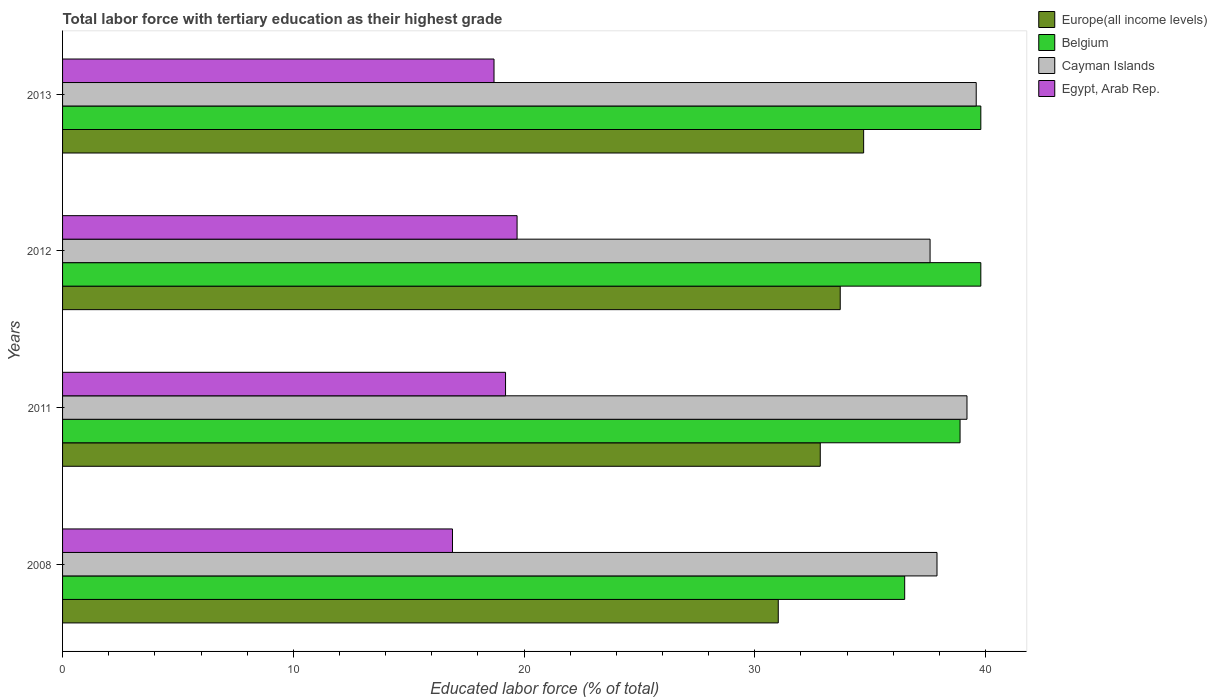How many different coloured bars are there?
Provide a succinct answer. 4. Are the number of bars per tick equal to the number of legend labels?
Offer a very short reply. Yes. How many bars are there on the 4th tick from the bottom?
Give a very brief answer. 4. In how many cases, is the number of bars for a given year not equal to the number of legend labels?
Your answer should be compact. 0. What is the percentage of male labor force with tertiary education in Egypt, Arab Rep. in 2008?
Offer a very short reply. 16.9. Across all years, what is the maximum percentage of male labor force with tertiary education in Egypt, Arab Rep.?
Keep it short and to the point. 19.7. Across all years, what is the minimum percentage of male labor force with tertiary education in Cayman Islands?
Provide a short and direct response. 37.6. In which year was the percentage of male labor force with tertiary education in Cayman Islands minimum?
Your answer should be compact. 2012. What is the total percentage of male labor force with tertiary education in Belgium in the graph?
Keep it short and to the point. 155. What is the difference between the percentage of male labor force with tertiary education in Belgium in 2008 and that in 2013?
Your answer should be very brief. -3.3. What is the difference between the percentage of male labor force with tertiary education in Belgium in 2011 and the percentage of male labor force with tertiary education in Europe(all income levels) in 2008?
Make the answer very short. 7.88. What is the average percentage of male labor force with tertiary education in Europe(all income levels) per year?
Give a very brief answer. 33.07. In the year 2012, what is the difference between the percentage of male labor force with tertiary education in Europe(all income levels) and percentage of male labor force with tertiary education in Belgium?
Provide a succinct answer. -6.09. In how many years, is the percentage of male labor force with tertiary education in Egypt, Arab Rep. greater than 12 %?
Your response must be concise. 4. What is the ratio of the percentage of male labor force with tertiary education in Egypt, Arab Rep. in 2011 to that in 2013?
Keep it short and to the point. 1.03. Is the difference between the percentage of male labor force with tertiary education in Europe(all income levels) in 2011 and 2013 greater than the difference between the percentage of male labor force with tertiary education in Belgium in 2011 and 2013?
Provide a succinct answer. No. What is the difference between the highest and the lowest percentage of male labor force with tertiary education in Egypt, Arab Rep.?
Provide a short and direct response. 2.8. In how many years, is the percentage of male labor force with tertiary education in Europe(all income levels) greater than the average percentage of male labor force with tertiary education in Europe(all income levels) taken over all years?
Provide a short and direct response. 2. Is the sum of the percentage of male labor force with tertiary education in Egypt, Arab Rep. in 2011 and 2013 greater than the maximum percentage of male labor force with tertiary education in Cayman Islands across all years?
Offer a very short reply. No. Is it the case that in every year, the sum of the percentage of male labor force with tertiary education in Europe(all income levels) and percentage of male labor force with tertiary education in Cayman Islands is greater than the sum of percentage of male labor force with tertiary education in Egypt, Arab Rep. and percentage of male labor force with tertiary education in Belgium?
Offer a very short reply. No. What does the 4th bar from the bottom in 2011 represents?
Ensure brevity in your answer.  Egypt, Arab Rep. Is it the case that in every year, the sum of the percentage of male labor force with tertiary education in Cayman Islands and percentage of male labor force with tertiary education in Belgium is greater than the percentage of male labor force with tertiary education in Egypt, Arab Rep.?
Your answer should be compact. Yes. How many bars are there?
Offer a very short reply. 16. Are all the bars in the graph horizontal?
Ensure brevity in your answer.  Yes. What is the difference between two consecutive major ticks on the X-axis?
Provide a short and direct response. 10. Are the values on the major ticks of X-axis written in scientific E-notation?
Offer a very short reply. No. Does the graph contain any zero values?
Offer a very short reply. No. How are the legend labels stacked?
Your answer should be very brief. Vertical. What is the title of the graph?
Your answer should be very brief. Total labor force with tertiary education as their highest grade. Does "OECD members" appear as one of the legend labels in the graph?
Provide a succinct answer. No. What is the label or title of the X-axis?
Ensure brevity in your answer.  Educated labor force (% of total). What is the label or title of the Y-axis?
Your response must be concise. Years. What is the Educated labor force (% of total) in Europe(all income levels) in 2008?
Make the answer very short. 31.02. What is the Educated labor force (% of total) of Belgium in 2008?
Provide a short and direct response. 36.5. What is the Educated labor force (% of total) of Cayman Islands in 2008?
Offer a very short reply. 37.9. What is the Educated labor force (% of total) of Egypt, Arab Rep. in 2008?
Offer a very short reply. 16.9. What is the Educated labor force (% of total) of Europe(all income levels) in 2011?
Provide a short and direct response. 32.84. What is the Educated labor force (% of total) of Belgium in 2011?
Give a very brief answer. 38.9. What is the Educated labor force (% of total) in Cayman Islands in 2011?
Your response must be concise. 39.2. What is the Educated labor force (% of total) of Egypt, Arab Rep. in 2011?
Make the answer very short. 19.2. What is the Educated labor force (% of total) of Europe(all income levels) in 2012?
Give a very brief answer. 33.71. What is the Educated labor force (% of total) of Belgium in 2012?
Ensure brevity in your answer.  39.8. What is the Educated labor force (% of total) in Cayman Islands in 2012?
Give a very brief answer. 37.6. What is the Educated labor force (% of total) of Egypt, Arab Rep. in 2012?
Provide a short and direct response. 19.7. What is the Educated labor force (% of total) in Europe(all income levels) in 2013?
Offer a terse response. 34.72. What is the Educated labor force (% of total) in Belgium in 2013?
Ensure brevity in your answer.  39.8. What is the Educated labor force (% of total) of Cayman Islands in 2013?
Provide a short and direct response. 39.6. What is the Educated labor force (% of total) of Egypt, Arab Rep. in 2013?
Ensure brevity in your answer.  18.7. Across all years, what is the maximum Educated labor force (% of total) of Europe(all income levels)?
Your answer should be compact. 34.72. Across all years, what is the maximum Educated labor force (% of total) in Belgium?
Offer a terse response. 39.8. Across all years, what is the maximum Educated labor force (% of total) in Cayman Islands?
Make the answer very short. 39.6. Across all years, what is the maximum Educated labor force (% of total) in Egypt, Arab Rep.?
Offer a very short reply. 19.7. Across all years, what is the minimum Educated labor force (% of total) in Europe(all income levels)?
Your answer should be compact. 31.02. Across all years, what is the minimum Educated labor force (% of total) in Belgium?
Offer a terse response. 36.5. Across all years, what is the minimum Educated labor force (% of total) of Cayman Islands?
Offer a very short reply. 37.6. Across all years, what is the minimum Educated labor force (% of total) of Egypt, Arab Rep.?
Provide a short and direct response. 16.9. What is the total Educated labor force (% of total) of Europe(all income levels) in the graph?
Provide a short and direct response. 132.29. What is the total Educated labor force (% of total) in Belgium in the graph?
Offer a terse response. 155. What is the total Educated labor force (% of total) of Cayman Islands in the graph?
Your response must be concise. 154.3. What is the total Educated labor force (% of total) of Egypt, Arab Rep. in the graph?
Make the answer very short. 74.5. What is the difference between the Educated labor force (% of total) of Europe(all income levels) in 2008 and that in 2011?
Ensure brevity in your answer.  -1.82. What is the difference between the Educated labor force (% of total) in Europe(all income levels) in 2008 and that in 2012?
Provide a short and direct response. -2.69. What is the difference between the Educated labor force (% of total) of Belgium in 2008 and that in 2012?
Offer a very short reply. -3.3. What is the difference between the Educated labor force (% of total) in Europe(all income levels) in 2008 and that in 2013?
Your answer should be compact. -3.7. What is the difference between the Educated labor force (% of total) of Europe(all income levels) in 2011 and that in 2012?
Provide a short and direct response. -0.87. What is the difference between the Educated labor force (% of total) in Cayman Islands in 2011 and that in 2012?
Your response must be concise. 1.6. What is the difference between the Educated labor force (% of total) in Europe(all income levels) in 2011 and that in 2013?
Offer a very short reply. -1.88. What is the difference between the Educated labor force (% of total) in Egypt, Arab Rep. in 2011 and that in 2013?
Offer a terse response. 0.5. What is the difference between the Educated labor force (% of total) of Europe(all income levels) in 2012 and that in 2013?
Offer a very short reply. -1.01. What is the difference between the Educated labor force (% of total) of Europe(all income levels) in 2008 and the Educated labor force (% of total) of Belgium in 2011?
Your response must be concise. -7.88. What is the difference between the Educated labor force (% of total) of Europe(all income levels) in 2008 and the Educated labor force (% of total) of Cayman Islands in 2011?
Offer a very short reply. -8.18. What is the difference between the Educated labor force (% of total) of Europe(all income levels) in 2008 and the Educated labor force (% of total) of Egypt, Arab Rep. in 2011?
Provide a short and direct response. 11.82. What is the difference between the Educated labor force (% of total) in Belgium in 2008 and the Educated labor force (% of total) in Egypt, Arab Rep. in 2011?
Give a very brief answer. 17.3. What is the difference between the Educated labor force (% of total) of Cayman Islands in 2008 and the Educated labor force (% of total) of Egypt, Arab Rep. in 2011?
Offer a very short reply. 18.7. What is the difference between the Educated labor force (% of total) in Europe(all income levels) in 2008 and the Educated labor force (% of total) in Belgium in 2012?
Keep it short and to the point. -8.78. What is the difference between the Educated labor force (% of total) of Europe(all income levels) in 2008 and the Educated labor force (% of total) of Cayman Islands in 2012?
Keep it short and to the point. -6.58. What is the difference between the Educated labor force (% of total) of Europe(all income levels) in 2008 and the Educated labor force (% of total) of Egypt, Arab Rep. in 2012?
Provide a short and direct response. 11.32. What is the difference between the Educated labor force (% of total) of Cayman Islands in 2008 and the Educated labor force (% of total) of Egypt, Arab Rep. in 2012?
Give a very brief answer. 18.2. What is the difference between the Educated labor force (% of total) in Europe(all income levels) in 2008 and the Educated labor force (% of total) in Belgium in 2013?
Make the answer very short. -8.78. What is the difference between the Educated labor force (% of total) of Europe(all income levels) in 2008 and the Educated labor force (% of total) of Cayman Islands in 2013?
Provide a short and direct response. -8.58. What is the difference between the Educated labor force (% of total) in Europe(all income levels) in 2008 and the Educated labor force (% of total) in Egypt, Arab Rep. in 2013?
Give a very brief answer. 12.32. What is the difference between the Educated labor force (% of total) in Belgium in 2008 and the Educated labor force (% of total) in Cayman Islands in 2013?
Give a very brief answer. -3.1. What is the difference between the Educated labor force (% of total) in Belgium in 2008 and the Educated labor force (% of total) in Egypt, Arab Rep. in 2013?
Offer a terse response. 17.8. What is the difference between the Educated labor force (% of total) in Cayman Islands in 2008 and the Educated labor force (% of total) in Egypt, Arab Rep. in 2013?
Make the answer very short. 19.2. What is the difference between the Educated labor force (% of total) in Europe(all income levels) in 2011 and the Educated labor force (% of total) in Belgium in 2012?
Your answer should be compact. -6.96. What is the difference between the Educated labor force (% of total) of Europe(all income levels) in 2011 and the Educated labor force (% of total) of Cayman Islands in 2012?
Offer a very short reply. -4.76. What is the difference between the Educated labor force (% of total) of Europe(all income levels) in 2011 and the Educated labor force (% of total) of Egypt, Arab Rep. in 2012?
Ensure brevity in your answer.  13.14. What is the difference between the Educated labor force (% of total) of Belgium in 2011 and the Educated labor force (% of total) of Cayman Islands in 2012?
Offer a very short reply. 1.3. What is the difference between the Educated labor force (% of total) of Europe(all income levels) in 2011 and the Educated labor force (% of total) of Belgium in 2013?
Keep it short and to the point. -6.96. What is the difference between the Educated labor force (% of total) of Europe(all income levels) in 2011 and the Educated labor force (% of total) of Cayman Islands in 2013?
Provide a succinct answer. -6.76. What is the difference between the Educated labor force (% of total) in Europe(all income levels) in 2011 and the Educated labor force (% of total) in Egypt, Arab Rep. in 2013?
Keep it short and to the point. 14.14. What is the difference between the Educated labor force (% of total) in Belgium in 2011 and the Educated labor force (% of total) in Egypt, Arab Rep. in 2013?
Your answer should be very brief. 20.2. What is the difference between the Educated labor force (% of total) of Cayman Islands in 2011 and the Educated labor force (% of total) of Egypt, Arab Rep. in 2013?
Offer a terse response. 20.5. What is the difference between the Educated labor force (% of total) of Europe(all income levels) in 2012 and the Educated labor force (% of total) of Belgium in 2013?
Your answer should be very brief. -6.09. What is the difference between the Educated labor force (% of total) of Europe(all income levels) in 2012 and the Educated labor force (% of total) of Cayman Islands in 2013?
Provide a short and direct response. -5.89. What is the difference between the Educated labor force (% of total) in Europe(all income levels) in 2012 and the Educated labor force (% of total) in Egypt, Arab Rep. in 2013?
Provide a succinct answer. 15.01. What is the difference between the Educated labor force (% of total) of Belgium in 2012 and the Educated labor force (% of total) of Egypt, Arab Rep. in 2013?
Give a very brief answer. 21.1. What is the difference between the Educated labor force (% of total) of Cayman Islands in 2012 and the Educated labor force (% of total) of Egypt, Arab Rep. in 2013?
Keep it short and to the point. 18.9. What is the average Educated labor force (% of total) of Europe(all income levels) per year?
Your answer should be compact. 33.07. What is the average Educated labor force (% of total) of Belgium per year?
Offer a terse response. 38.75. What is the average Educated labor force (% of total) of Cayman Islands per year?
Offer a terse response. 38.58. What is the average Educated labor force (% of total) in Egypt, Arab Rep. per year?
Offer a terse response. 18.62. In the year 2008, what is the difference between the Educated labor force (% of total) in Europe(all income levels) and Educated labor force (% of total) in Belgium?
Provide a succinct answer. -5.48. In the year 2008, what is the difference between the Educated labor force (% of total) of Europe(all income levels) and Educated labor force (% of total) of Cayman Islands?
Ensure brevity in your answer.  -6.88. In the year 2008, what is the difference between the Educated labor force (% of total) in Europe(all income levels) and Educated labor force (% of total) in Egypt, Arab Rep.?
Provide a short and direct response. 14.12. In the year 2008, what is the difference between the Educated labor force (% of total) in Belgium and Educated labor force (% of total) in Egypt, Arab Rep.?
Give a very brief answer. 19.6. In the year 2008, what is the difference between the Educated labor force (% of total) in Cayman Islands and Educated labor force (% of total) in Egypt, Arab Rep.?
Offer a terse response. 21. In the year 2011, what is the difference between the Educated labor force (% of total) of Europe(all income levels) and Educated labor force (% of total) of Belgium?
Offer a terse response. -6.06. In the year 2011, what is the difference between the Educated labor force (% of total) in Europe(all income levels) and Educated labor force (% of total) in Cayman Islands?
Make the answer very short. -6.36. In the year 2011, what is the difference between the Educated labor force (% of total) in Europe(all income levels) and Educated labor force (% of total) in Egypt, Arab Rep.?
Your answer should be compact. 13.64. In the year 2011, what is the difference between the Educated labor force (% of total) of Belgium and Educated labor force (% of total) of Egypt, Arab Rep.?
Your answer should be very brief. 19.7. In the year 2012, what is the difference between the Educated labor force (% of total) of Europe(all income levels) and Educated labor force (% of total) of Belgium?
Keep it short and to the point. -6.09. In the year 2012, what is the difference between the Educated labor force (% of total) of Europe(all income levels) and Educated labor force (% of total) of Cayman Islands?
Give a very brief answer. -3.89. In the year 2012, what is the difference between the Educated labor force (% of total) of Europe(all income levels) and Educated labor force (% of total) of Egypt, Arab Rep.?
Keep it short and to the point. 14.01. In the year 2012, what is the difference between the Educated labor force (% of total) in Belgium and Educated labor force (% of total) in Cayman Islands?
Your answer should be compact. 2.2. In the year 2012, what is the difference between the Educated labor force (% of total) of Belgium and Educated labor force (% of total) of Egypt, Arab Rep.?
Ensure brevity in your answer.  20.1. In the year 2012, what is the difference between the Educated labor force (% of total) of Cayman Islands and Educated labor force (% of total) of Egypt, Arab Rep.?
Offer a terse response. 17.9. In the year 2013, what is the difference between the Educated labor force (% of total) in Europe(all income levels) and Educated labor force (% of total) in Belgium?
Your response must be concise. -5.08. In the year 2013, what is the difference between the Educated labor force (% of total) in Europe(all income levels) and Educated labor force (% of total) in Cayman Islands?
Provide a succinct answer. -4.88. In the year 2013, what is the difference between the Educated labor force (% of total) of Europe(all income levels) and Educated labor force (% of total) of Egypt, Arab Rep.?
Make the answer very short. 16.02. In the year 2013, what is the difference between the Educated labor force (% of total) in Belgium and Educated labor force (% of total) in Egypt, Arab Rep.?
Provide a short and direct response. 21.1. In the year 2013, what is the difference between the Educated labor force (% of total) of Cayman Islands and Educated labor force (% of total) of Egypt, Arab Rep.?
Provide a succinct answer. 20.9. What is the ratio of the Educated labor force (% of total) in Europe(all income levels) in 2008 to that in 2011?
Give a very brief answer. 0.94. What is the ratio of the Educated labor force (% of total) in Belgium in 2008 to that in 2011?
Your answer should be very brief. 0.94. What is the ratio of the Educated labor force (% of total) in Cayman Islands in 2008 to that in 2011?
Make the answer very short. 0.97. What is the ratio of the Educated labor force (% of total) of Egypt, Arab Rep. in 2008 to that in 2011?
Offer a very short reply. 0.88. What is the ratio of the Educated labor force (% of total) of Europe(all income levels) in 2008 to that in 2012?
Ensure brevity in your answer.  0.92. What is the ratio of the Educated labor force (% of total) of Belgium in 2008 to that in 2012?
Offer a terse response. 0.92. What is the ratio of the Educated labor force (% of total) of Cayman Islands in 2008 to that in 2012?
Ensure brevity in your answer.  1.01. What is the ratio of the Educated labor force (% of total) of Egypt, Arab Rep. in 2008 to that in 2012?
Give a very brief answer. 0.86. What is the ratio of the Educated labor force (% of total) in Europe(all income levels) in 2008 to that in 2013?
Provide a succinct answer. 0.89. What is the ratio of the Educated labor force (% of total) in Belgium in 2008 to that in 2013?
Make the answer very short. 0.92. What is the ratio of the Educated labor force (% of total) of Cayman Islands in 2008 to that in 2013?
Provide a succinct answer. 0.96. What is the ratio of the Educated labor force (% of total) in Egypt, Arab Rep. in 2008 to that in 2013?
Give a very brief answer. 0.9. What is the ratio of the Educated labor force (% of total) in Europe(all income levels) in 2011 to that in 2012?
Provide a short and direct response. 0.97. What is the ratio of the Educated labor force (% of total) of Belgium in 2011 to that in 2012?
Keep it short and to the point. 0.98. What is the ratio of the Educated labor force (% of total) of Cayman Islands in 2011 to that in 2012?
Provide a short and direct response. 1.04. What is the ratio of the Educated labor force (% of total) of Egypt, Arab Rep. in 2011 to that in 2012?
Provide a short and direct response. 0.97. What is the ratio of the Educated labor force (% of total) in Europe(all income levels) in 2011 to that in 2013?
Your response must be concise. 0.95. What is the ratio of the Educated labor force (% of total) of Belgium in 2011 to that in 2013?
Give a very brief answer. 0.98. What is the ratio of the Educated labor force (% of total) in Cayman Islands in 2011 to that in 2013?
Your response must be concise. 0.99. What is the ratio of the Educated labor force (% of total) in Egypt, Arab Rep. in 2011 to that in 2013?
Give a very brief answer. 1.03. What is the ratio of the Educated labor force (% of total) in Europe(all income levels) in 2012 to that in 2013?
Provide a succinct answer. 0.97. What is the ratio of the Educated labor force (% of total) of Cayman Islands in 2012 to that in 2013?
Your answer should be compact. 0.95. What is the ratio of the Educated labor force (% of total) in Egypt, Arab Rep. in 2012 to that in 2013?
Make the answer very short. 1.05. What is the difference between the highest and the second highest Educated labor force (% of total) of Europe(all income levels)?
Your answer should be very brief. 1.01. What is the difference between the highest and the second highest Educated labor force (% of total) in Cayman Islands?
Provide a succinct answer. 0.4. What is the difference between the highest and the lowest Educated labor force (% of total) in Europe(all income levels)?
Offer a very short reply. 3.7. What is the difference between the highest and the lowest Educated labor force (% of total) in Belgium?
Give a very brief answer. 3.3. What is the difference between the highest and the lowest Educated labor force (% of total) in Egypt, Arab Rep.?
Your answer should be compact. 2.8. 